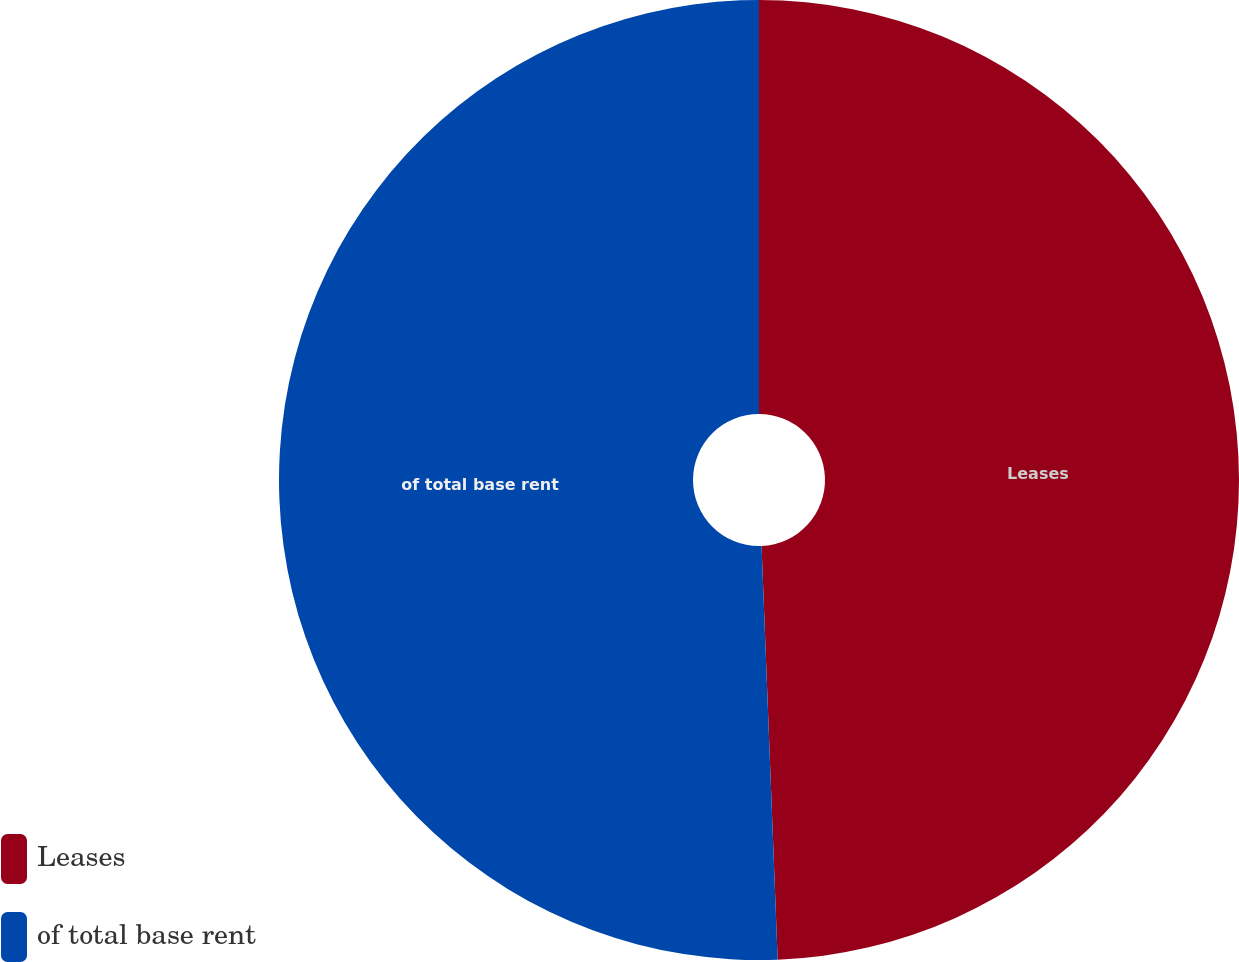Convert chart. <chart><loc_0><loc_0><loc_500><loc_500><pie_chart><fcel>Leases<fcel>of total base rent<nl><fcel>49.38%<fcel>50.62%<nl></chart> 